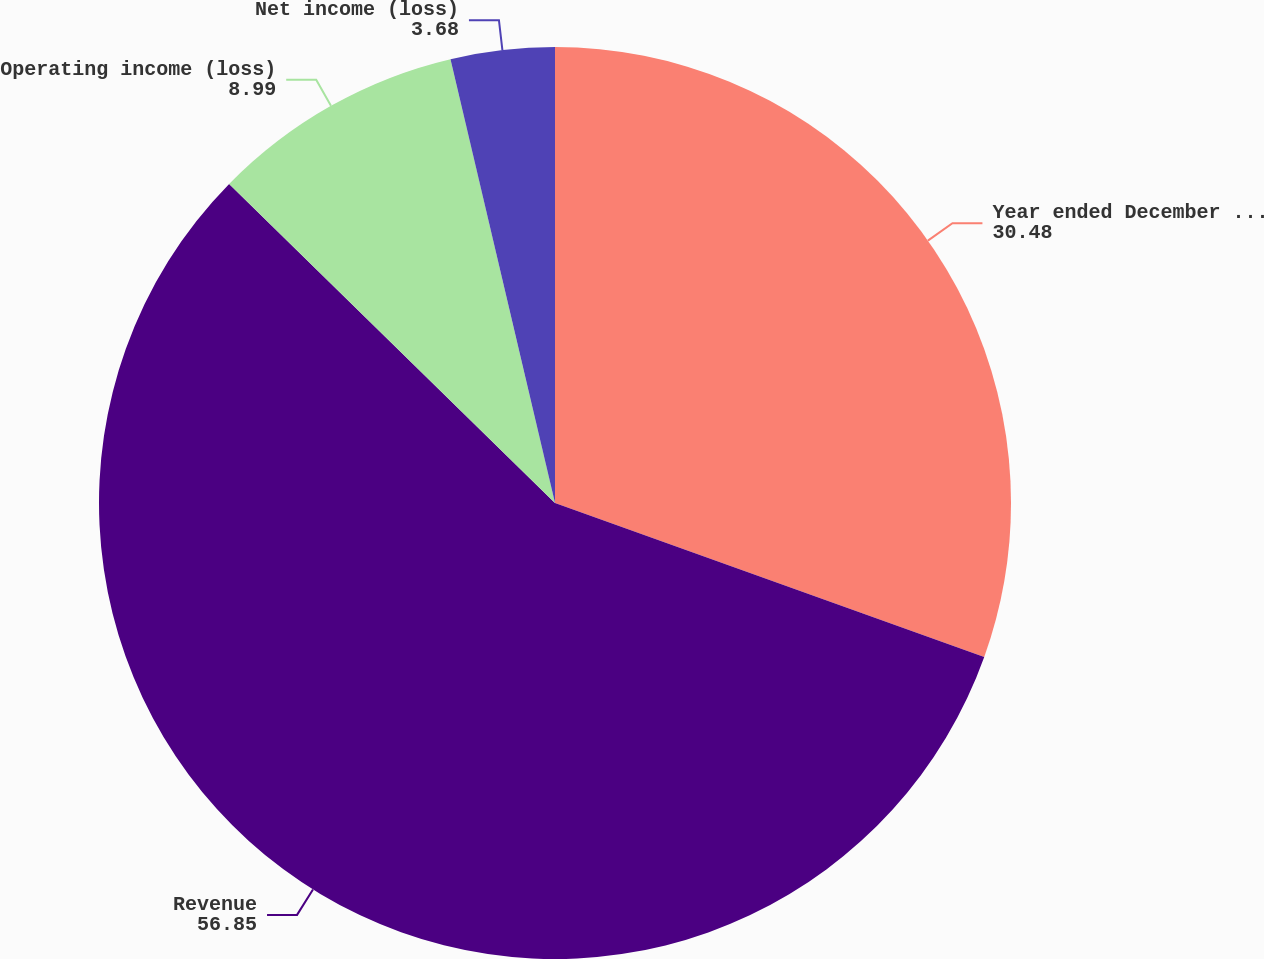Convert chart. <chart><loc_0><loc_0><loc_500><loc_500><pie_chart><fcel>Year ended December 31 (in<fcel>Revenue<fcel>Operating income (loss)<fcel>Net income (loss)<nl><fcel>30.48%<fcel>56.85%<fcel>8.99%<fcel>3.68%<nl></chart> 